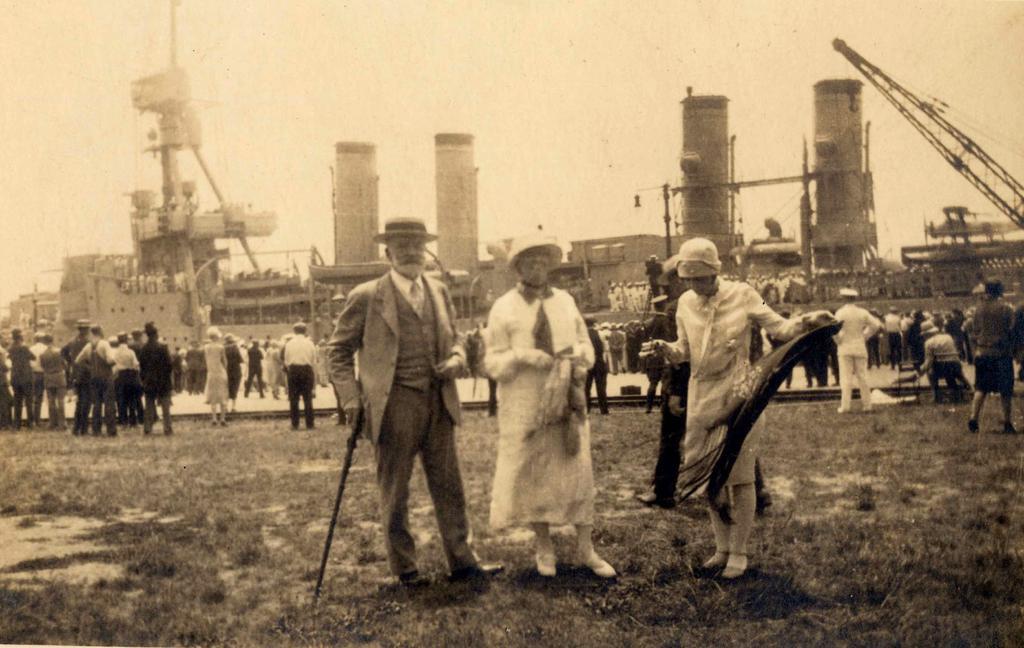How would you summarize this image in a sentence or two? In this image, we can see people. Few people are standing on the grass. In the middle of the image, people are holding some objects. In the background, there is a ship, containers, poles and some objects. 